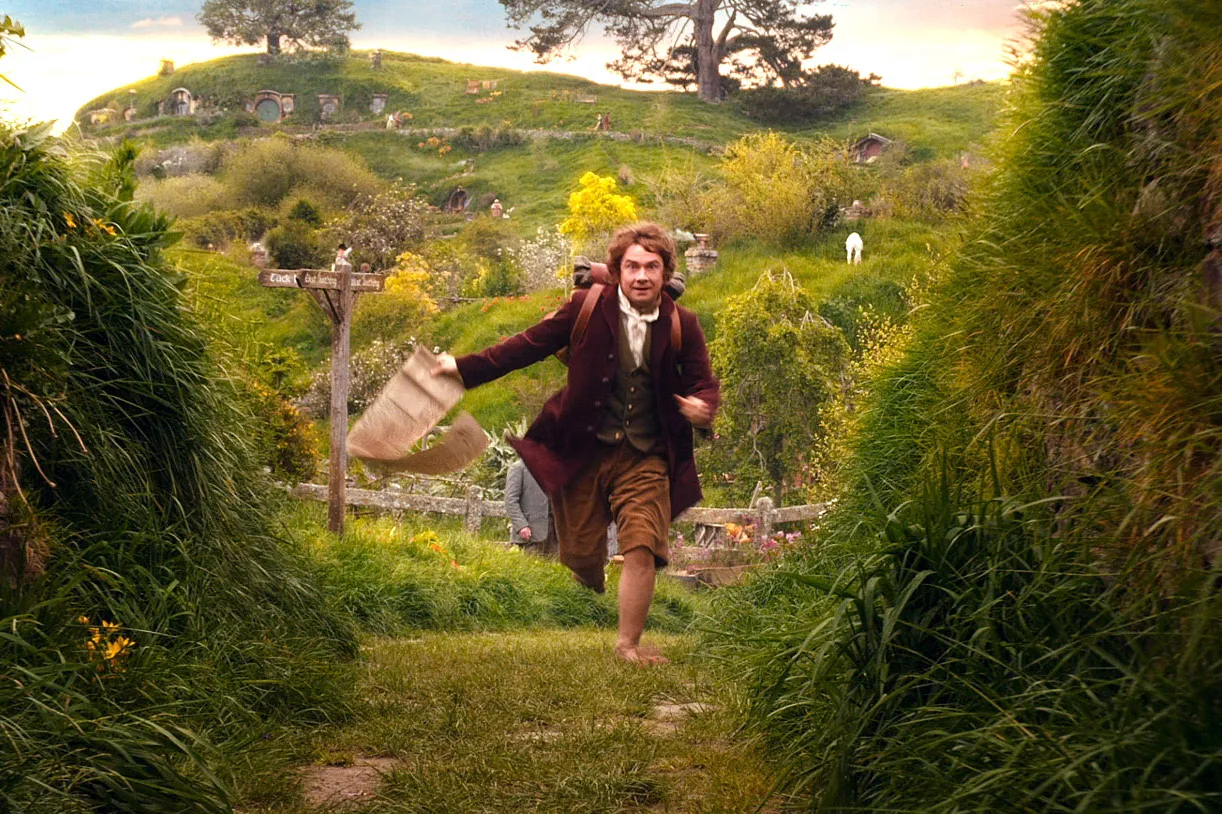What kind of interaction do you imagine could be happening between the characters in the background? I imagine the characters in the background could be engaged in a light-hearted conversation or perhaps sharing stories of their daily lives in the Shire. They might also be discussing local news or the recent adventures of Bilbo Baggins, adding to the warm and communal atmosphere typical of hobbit society. 